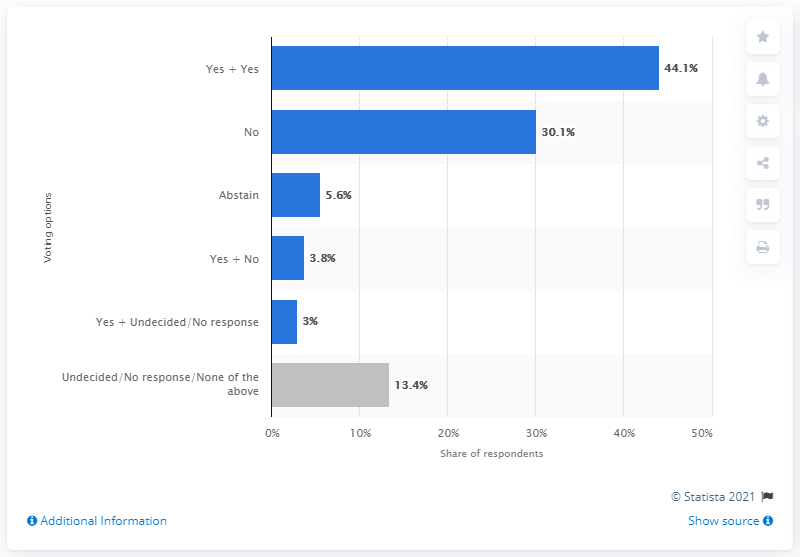List a handful of essential elements in this visual. According to the survey, 3.8% of respondents supported Catalonia becoming a state but not independent from Spain. 